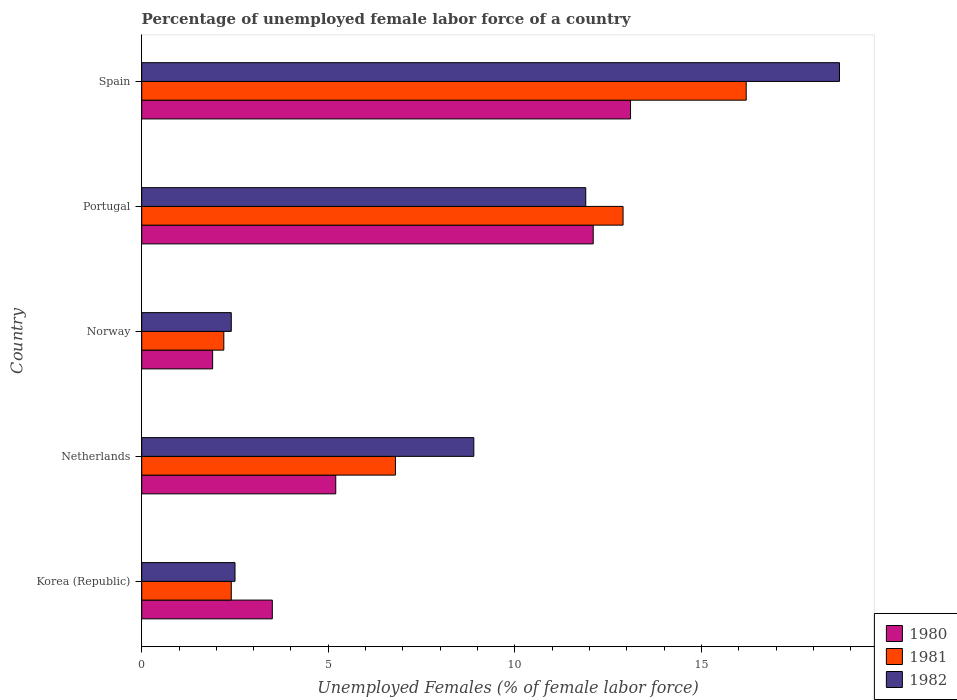Are the number of bars on each tick of the Y-axis equal?
Offer a terse response. Yes. How many bars are there on the 5th tick from the bottom?
Keep it short and to the point. 3. What is the label of the 4th group of bars from the top?
Your response must be concise. Netherlands. What is the percentage of unemployed female labor force in 1982 in Portugal?
Give a very brief answer. 11.9. Across all countries, what is the maximum percentage of unemployed female labor force in 1981?
Provide a succinct answer. 16.2. Across all countries, what is the minimum percentage of unemployed female labor force in 1981?
Your answer should be very brief. 2.2. In which country was the percentage of unemployed female labor force in 1981 maximum?
Offer a very short reply. Spain. What is the total percentage of unemployed female labor force in 1981 in the graph?
Your answer should be compact. 40.5. What is the difference between the percentage of unemployed female labor force in 1980 in Netherlands and that in Spain?
Give a very brief answer. -7.9. What is the difference between the percentage of unemployed female labor force in 1980 in Netherlands and the percentage of unemployed female labor force in 1982 in Korea (Republic)?
Your answer should be compact. 2.7. What is the average percentage of unemployed female labor force in 1981 per country?
Ensure brevity in your answer.  8.1. What is the difference between the percentage of unemployed female labor force in 1982 and percentage of unemployed female labor force in 1980 in Spain?
Give a very brief answer. 5.6. What is the ratio of the percentage of unemployed female labor force in 1980 in Portugal to that in Spain?
Make the answer very short. 0.92. Is the percentage of unemployed female labor force in 1981 in Korea (Republic) less than that in Netherlands?
Provide a short and direct response. Yes. What is the difference between the highest and the second highest percentage of unemployed female labor force in 1982?
Provide a short and direct response. 6.8. What is the difference between the highest and the lowest percentage of unemployed female labor force in 1980?
Offer a very short reply. 11.2. In how many countries, is the percentage of unemployed female labor force in 1980 greater than the average percentage of unemployed female labor force in 1980 taken over all countries?
Offer a terse response. 2. What does the 3rd bar from the top in Korea (Republic) represents?
Your answer should be very brief. 1980. Is it the case that in every country, the sum of the percentage of unemployed female labor force in 1981 and percentage of unemployed female labor force in 1982 is greater than the percentage of unemployed female labor force in 1980?
Provide a short and direct response. Yes. How many countries are there in the graph?
Ensure brevity in your answer.  5. What is the difference between two consecutive major ticks on the X-axis?
Your answer should be compact. 5. Where does the legend appear in the graph?
Keep it short and to the point. Bottom right. How many legend labels are there?
Offer a very short reply. 3. How are the legend labels stacked?
Offer a terse response. Vertical. What is the title of the graph?
Provide a succinct answer. Percentage of unemployed female labor force of a country. Does "1979" appear as one of the legend labels in the graph?
Provide a short and direct response. No. What is the label or title of the X-axis?
Your answer should be compact. Unemployed Females (% of female labor force). What is the label or title of the Y-axis?
Your response must be concise. Country. What is the Unemployed Females (% of female labor force) of 1981 in Korea (Republic)?
Your answer should be very brief. 2.4. What is the Unemployed Females (% of female labor force) of 1980 in Netherlands?
Provide a succinct answer. 5.2. What is the Unemployed Females (% of female labor force) in 1981 in Netherlands?
Provide a short and direct response. 6.8. What is the Unemployed Females (% of female labor force) in 1982 in Netherlands?
Make the answer very short. 8.9. What is the Unemployed Females (% of female labor force) of 1980 in Norway?
Your answer should be very brief. 1.9. What is the Unemployed Females (% of female labor force) in 1981 in Norway?
Offer a terse response. 2.2. What is the Unemployed Females (% of female labor force) in 1982 in Norway?
Provide a short and direct response. 2.4. What is the Unemployed Females (% of female labor force) in 1980 in Portugal?
Offer a very short reply. 12.1. What is the Unemployed Females (% of female labor force) of 1981 in Portugal?
Provide a short and direct response. 12.9. What is the Unemployed Females (% of female labor force) in 1982 in Portugal?
Offer a terse response. 11.9. What is the Unemployed Females (% of female labor force) in 1980 in Spain?
Offer a very short reply. 13.1. What is the Unemployed Females (% of female labor force) of 1981 in Spain?
Your answer should be compact. 16.2. What is the Unemployed Females (% of female labor force) of 1982 in Spain?
Ensure brevity in your answer.  18.7. Across all countries, what is the maximum Unemployed Females (% of female labor force) in 1980?
Offer a very short reply. 13.1. Across all countries, what is the maximum Unemployed Females (% of female labor force) of 1981?
Offer a terse response. 16.2. Across all countries, what is the maximum Unemployed Females (% of female labor force) in 1982?
Offer a very short reply. 18.7. Across all countries, what is the minimum Unemployed Females (% of female labor force) in 1980?
Give a very brief answer. 1.9. Across all countries, what is the minimum Unemployed Females (% of female labor force) of 1981?
Offer a very short reply. 2.2. Across all countries, what is the minimum Unemployed Females (% of female labor force) of 1982?
Give a very brief answer. 2.4. What is the total Unemployed Females (% of female labor force) in 1980 in the graph?
Provide a succinct answer. 35.8. What is the total Unemployed Females (% of female labor force) in 1981 in the graph?
Your response must be concise. 40.5. What is the total Unemployed Females (% of female labor force) in 1982 in the graph?
Ensure brevity in your answer.  44.4. What is the difference between the Unemployed Females (% of female labor force) in 1980 in Korea (Republic) and that in Netherlands?
Give a very brief answer. -1.7. What is the difference between the Unemployed Females (% of female labor force) of 1981 in Korea (Republic) and that in Netherlands?
Provide a succinct answer. -4.4. What is the difference between the Unemployed Females (% of female labor force) of 1982 in Korea (Republic) and that in Netherlands?
Offer a very short reply. -6.4. What is the difference between the Unemployed Females (% of female labor force) of 1982 in Korea (Republic) and that in Norway?
Give a very brief answer. 0.1. What is the difference between the Unemployed Females (% of female labor force) of 1982 in Korea (Republic) and that in Portugal?
Ensure brevity in your answer.  -9.4. What is the difference between the Unemployed Females (% of female labor force) in 1980 in Korea (Republic) and that in Spain?
Your response must be concise. -9.6. What is the difference between the Unemployed Females (% of female labor force) in 1982 in Korea (Republic) and that in Spain?
Provide a short and direct response. -16.2. What is the difference between the Unemployed Females (% of female labor force) in 1980 in Netherlands and that in Norway?
Your answer should be compact. 3.3. What is the difference between the Unemployed Females (% of female labor force) in 1981 in Netherlands and that in Norway?
Your answer should be very brief. 4.6. What is the difference between the Unemployed Females (% of female labor force) in 1982 in Netherlands and that in Norway?
Make the answer very short. 6.5. What is the difference between the Unemployed Females (% of female labor force) of 1981 in Netherlands and that in Spain?
Give a very brief answer. -9.4. What is the difference between the Unemployed Females (% of female labor force) in 1982 in Netherlands and that in Spain?
Make the answer very short. -9.8. What is the difference between the Unemployed Females (% of female labor force) of 1980 in Norway and that in Portugal?
Provide a succinct answer. -10.2. What is the difference between the Unemployed Females (% of female labor force) in 1982 in Norway and that in Spain?
Your response must be concise. -16.3. What is the difference between the Unemployed Females (% of female labor force) of 1980 in Portugal and that in Spain?
Make the answer very short. -1. What is the difference between the Unemployed Females (% of female labor force) of 1980 in Korea (Republic) and the Unemployed Females (% of female labor force) of 1981 in Netherlands?
Give a very brief answer. -3.3. What is the difference between the Unemployed Females (% of female labor force) in 1981 in Korea (Republic) and the Unemployed Females (% of female labor force) in 1982 in Netherlands?
Provide a succinct answer. -6.5. What is the difference between the Unemployed Females (% of female labor force) in 1980 in Korea (Republic) and the Unemployed Females (% of female labor force) in 1982 in Norway?
Offer a very short reply. 1.1. What is the difference between the Unemployed Females (% of female labor force) in 1980 in Korea (Republic) and the Unemployed Females (% of female labor force) in 1981 in Portugal?
Offer a very short reply. -9.4. What is the difference between the Unemployed Females (% of female labor force) in 1980 in Korea (Republic) and the Unemployed Females (% of female labor force) in 1982 in Spain?
Ensure brevity in your answer.  -15.2. What is the difference between the Unemployed Females (% of female labor force) in 1981 in Korea (Republic) and the Unemployed Females (% of female labor force) in 1982 in Spain?
Make the answer very short. -16.3. What is the difference between the Unemployed Females (% of female labor force) in 1981 in Netherlands and the Unemployed Females (% of female labor force) in 1982 in Norway?
Provide a succinct answer. 4.4. What is the difference between the Unemployed Females (% of female labor force) of 1980 in Netherlands and the Unemployed Females (% of female labor force) of 1981 in Portugal?
Provide a succinct answer. -7.7. What is the difference between the Unemployed Females (% of female labor force) in 1981 in Netherlands and the Unemployed Females (% of female labor force) in 1982 in Portugal?
Offer a terse response. -5.1. What is the difference between the Unemployed Females (% of female labor force) in 1980 in Netherlands and the Unemployed Females (% of female labor force) in 1982 in Spain?
Offer a terse response. -13.5. What is the difference between the Unemployed Females (% of female labor force) in 1980 in Norway and the Unemployed Females (% of female labor force) in 1981 in Portugal?
Your answer should be very brief. -11. What is the difference between the Unemployed Females (% of female labor force) in 1980 in Norway and the Unemployed Females (% of female labor force) in 1982 in Portugal?
Keep it short and to the point. -10. What is the difference between the Unemployed Females (% of female labor force) in 1981 in Norway and the Unemployed Females (% of female labor force) in 1982 in Portugal?
Your answer should be very brief. -9.7. What is the difference between the Unemployed Females (% of female labor force) in 1980 in Norway and the Unemployed Females (% of female labor force) in 1981 in Spain?
Keep it short and to the point. -14.3. What is the difference between the Unemployed Females (% of female labor force) of 1980 in Norway and the Unemployed Females (% of female labor force) of 1982 in Spain?
Offer a terse response. -16.8. What is the difference between the Unemployed Females (% of female labor force) in 1981 in Norway and the Unemployed Females (% of female labor force) in 1982 in Spain?
Your answer should be very brief. -16.5. What is the difference between the Unemployed Females (% of female labor force) of 1980 in Portugal and the Unemployed Females (% of female labor force) of 1982 in Spain?
Your answer should be very brief. -6.6. What is the difference between the Unemployed Females (% of female labor force) in 1981 in Portugal and the Unemployed Females (% of female labor force) in 1982 in Spain?
Provide a short and direct response. -5.8. What is the average Unemployed Females (% of female labor force) in 1980 per country?
Offer a terse response. 7.16. What is the average Unemployed Females (% of female labor force) of 1981 per country?
Your answer should be compact. 8.1. What is the average Unemployed Females (% of female labor force) in 1982 per country?
Offer a terse response. 8.88. What is the difference between the Unemployed Females (% of female labor force) of 1980 and Unemployed Females (% of female labor force) of 1981 in Korea (Republic)?
Your answer should be very brief. 1.1. What is the difference between the Unemployed Females (% of female labor force) in 1980 and Unemployed Females (% of female labor force) in 1982 in Korea (Republic)?
Make the answer very short. 1. What is the difference between the Unemployed Females (% of female labor force) in 1981 and Unemployed Females (% of female labor force) in 1982 in Korea (Republic)?
Make the answer very short. -0.1. What is the difference between the Unemployed Females (% of female labor force) of 1980 and Unemployed Females (% of female labor force) of 1981 in Netherlands?
Give a very brief answer. -1.6. What is the difference between the Unemployed Females (% of female labor force) of 1980 and Unemployed Females (% of female labor force) of 1982 in Netherlands?
Provide a short and direct response. -3.7. What is the difference between the Unemployed Females (% of female labor force) in 1981 and Unemployed Females (% of female labor force) in 1982 in Netherlands?
Give a very brief answer. -2.1. What is the difference between the Unemployed Females (% of female labor force) of 1980 and Unemployed Females (% of female labor force) of 1982 in Norway?
Your answer should be very brief. -0.5. What is the difference between the Unemployed Females (% of female labor force) in 1980 and Unemployed Females (% of female labor force) in 1981 in Portugal?
Give a very brief answer. -0.8. What is the difference between the Unemployed Females (% of female labor force) of 1980 and Unemployed Females (% of female labor force) of 1981 in Spain?
Offer a terse response. -3.1. What is the difference between the Unemployed Females (% of female labor force) in 1980 and Unemployed Females (% of female labor force) in 1982 in Spain?
Provide a short and direct response. -5.6. What is the difference between the Unemployed Females (% of female labor force) of 1981 and Unemployed Females (% of female labor force) of 1982 in Spain?
Give a very brief answer. -2.5. What is the ratio of the Unemployed Females (% of female labor force) in 1980 in Korea (Republic) to that in Netherlands?
Your answer should be compact. 0.67. What is the ratio of the Unemployed Females (% of female labor force) in 1981 in Korea (Republic) to that in Netherlands?
Offer a very short reply. 0.35. What is the ratio of the Unemployed Females (% of female labor force) in 1982 in Korea (Republic) to that in Netherlands?
Your answer should be very brief. 0.28. What is the ratio of the Unemployed Females (% of female labor force) of 1980 in Korea (Republic) to that in Norway?
Keep it short and to the point. 1.84. What is the ratio of the Unemployed Females (% of female labor force) in 1982 in Korea (Republic) to that in Norway?
Offer a terse response. 1.04. What is the ratio of the Unemployed Females (% of female labor force) in 1980 in Korea (Republic) to that in Portugal?
Ensure brevity in your answer.  0.29. What is the ratio of the Unemployed Females (% of female labor force) of 1981 in Korea (Republic) to that in Portugal?
Make the answer very short. 0.19. What is the ratio of the Unemployed Females (% of female labor force) of 1982 in Korea (Republic) to that in Portugal?
Ensure brevity in your answer.  0.21. What is the ratio of the Unemployed Females (% of female labor force) of 1980 in Korea (Republic) to that in Spain?
Your answer should be compact. 0.27. What is the ratio of the Unemployed Females (% of female labor force) of 1981 in Korea (Republic) to that in Spain?
Keep it short and to the point. 0.15. What is the ratio of the Unemployed Females (% of female labor force) in 1982 in Korea (Republic) to that in Spain?
Offer a very short reply. 0.13. What is the ratio of the Unemployed Females (% of female labor force) of 1980 in Netherlands to that in Norway?
Your answer should be very brief. 2.74. What is the ratio of the Unemployed Females (% of female labor force) of 1981 in Netherlands to that in Norway?
Give a very brief answer. 3.09. What is the ratio of the Unemployed Females (% of female labor force) of 1982 in Netherlands to that in Norway?
Offer a terse response. 3.71. What is the ratio of the Unemployed Females (% of female labor force) in 1980 in Netherlands to that in Portugal?
Ensure brevity in your answer.  0.43. What is the ratio of the Unemployed Females (% of female labor force) of 1981 in Netherlands to that in Portugal?
Provide a succinct answer. 0.53. What is the ratio of the Unemployed Females (% of female labor force) in 1982 in Netherlands to that in Portugal?
Your answer should be compact. 0.75. What is the ratio of the Unemployed Females (% of female labor force) in 1980 in Netherlands to that in Spain?
Make the answer very short. 0.4. What is the ratio of the Unemployed Females (% of female labor force) in 1981 in Netherlands to that in Spain?
Your response must be concise. 0.42. What is the ratio of the Unemployed Females (% of female labor force) in 1982 in Netherlands to that in Spain?
Your answer should be compact. 0.48. What is the ratio of the Unemployed Females (% of female labor force) in 1980 in Norway to that in Portugal?
Your answer should be compact. 0.16. What is the ratio of the Unemployed Females (% of female labor force) in 1981 in Norway to that in Portugal?
Ensure brevity in your answer.  0.17. What is the ratio of the Unemployed Females (% of female labor force) in 1982 in Norway to that in Portugal?
Provide a short and direct response. 0.2. What is the ratio of the Unemployed Females (% of female labor force) in 1980 in Norway to that in Spain?
Ensure brevity in your answer.  0.14. What is the ratio of the Unemployed Females (% of female labor force) in 1981 in Norway to that in Spain?
Offer a terse response. 0.14. What is the ratio of the Unemployed Females (% of female labor force) of 1982 in Norway to that in Spain?
Your answer should be compact. 0.13. What is the ratio of the Unemployed Females (% of female labor force) in 1980 in Portugal to that in Spain?
Ensure brevity in your answer.  0.92. What is the ratio of the Unemployed Females (% of female labor force) in 1981 in Portugal to that in Spain?
Your response must be concise. 0.8. What is the ratio of the Unemployed Females (% of female labor force) in 1982 in Portugal to that in Spain?
Offer a terse response. 0.64. What is the difference between the highest and the second highest Unemployed Females (% of female labor force) of 1982?
Provide a succinct answer. 6.8. What is the difference between the highest and the lowest Unemployed Females (% of female labor force) of 1980?
Your response must be concise. 11.2. What is the difference between the highest and the lowest Unemployed Females (% of female labor force) of 1981?
Provide a succinct answer. 14. What is the difference between the highest and the lowest Unemployed Females (% of female labor force) of 1982?
Make the answer very short. 16.3. 